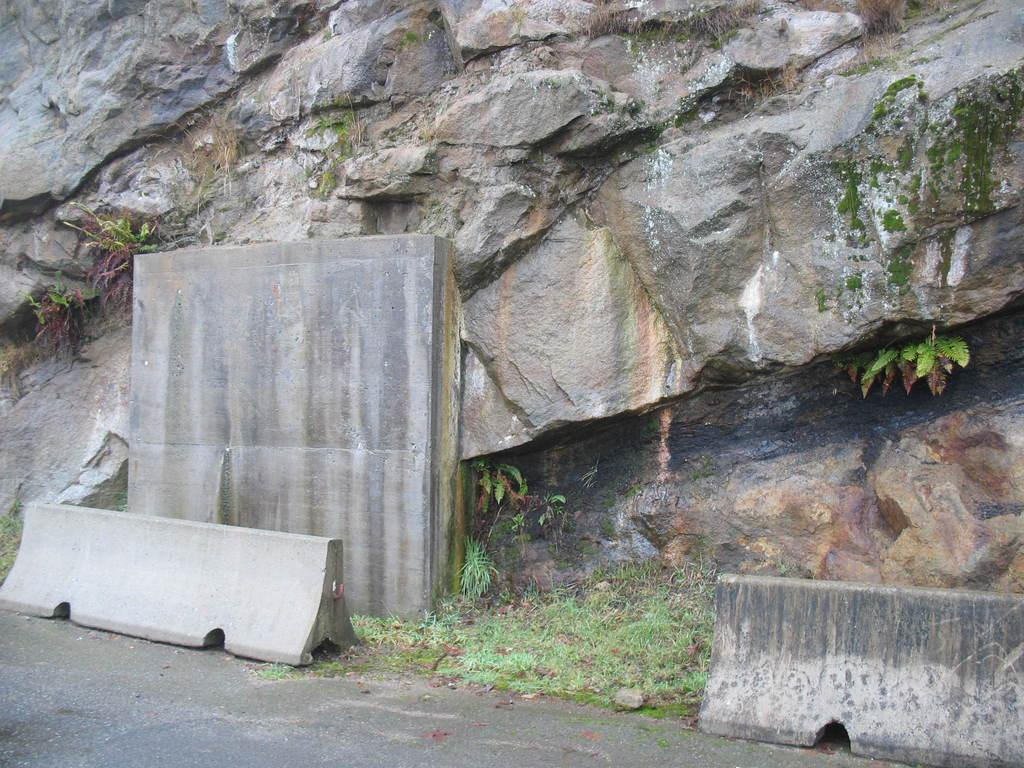What type of geological formation is present in the image? There is a stone mountain in the image. What type of vegetation can be seen near the road at the bottom of the image? Grass is visible near the road at the bottom of the image. What feature separates the road on the left side of the image? There is a divider on the left side of the image. What direction is the cub facing in the image? There is no cub present in the image. How many quarters are visible on the stone mountain in the image? There are no quarters present in the image. 